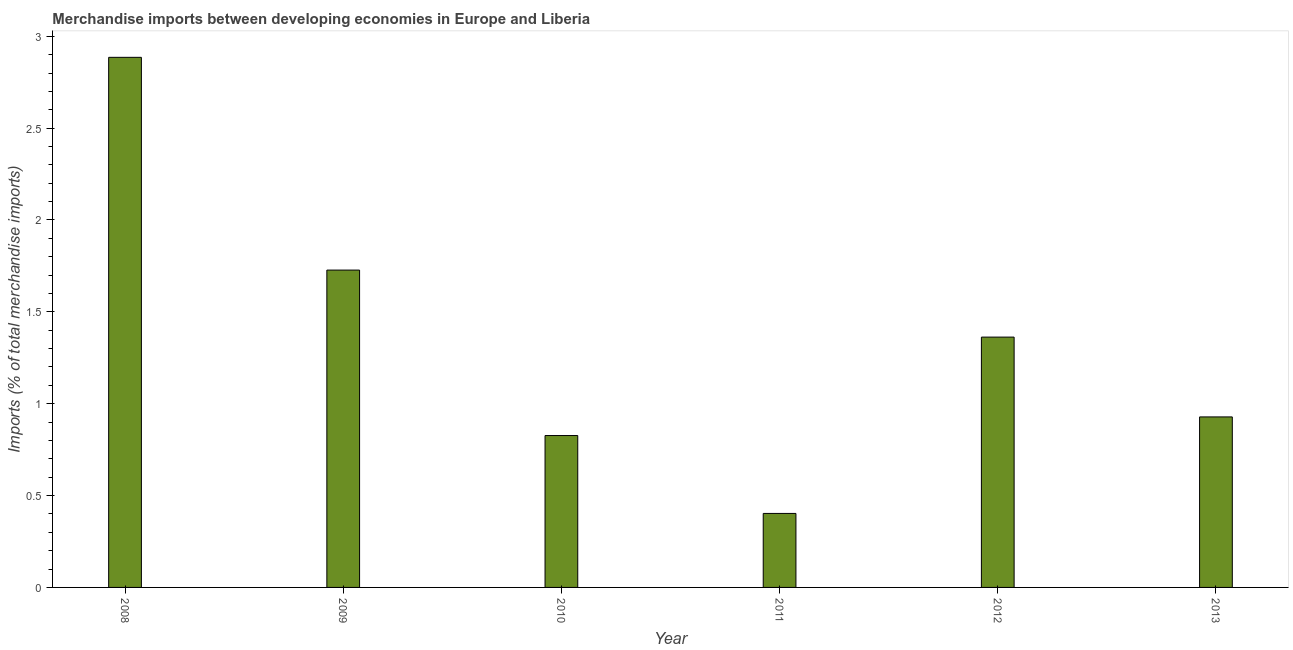Does the graph contain any zero values?
Offer a very short reply. No. What is the title of the graph?
Make the answer very short. Merchandise imports between developing economies in Europe and Liberia. What is the label or title of the X-axis?
Give a very brief answer. Year. What is the label or title of the Y-axis?
Provide a succinct answer. Imports (% of total merchandise imports). What is the merchandise imports in 2011?
Give a very brief answer. 0.4. Across all years, what is the maximum merchandise imports?
Your response must be concise. 2.89. Across all years, what is the minimum merchandise imports?
Make the answer very short. 0.4. In which year was the merchandise imports maximum?
Your answer should be very brief. 2008. What is the sum of the merchandise imports?
Your answer should be compact. 8.13. What is the difference between the merchandise imports in 2009 and 2013?
Give a very brief answer. 0.8. What is the average merchandise imports per year?
Keep it short and to the point. 1.35. What is the median merchandise imports?
Keep it short and to the point. 1.15. In how many years, is the merchandise imports greater than 1.3 %?
Offer a terse response. 3. What is the ratio of the merchandise imports in 2010 to that in 2012?
Provide a succinct answer. 0.61. Is the merchandise imports in 2008 less than that in 2011?
Your answer should be very brief. No. Is the difference between the merchandise imports in 2010 and 2012 greater than the difference between any two years?
Give a very brief answer. No. What is the difference between the highest and the second highest merchandise imports?
Provide a short and direct response. 1.16. Is the sum of the merchandise imports in 2011 and 2012 greater than the maximum merchandise imports across all years?
Provide a succinct answer. No. What is the difference between the highest and the lowest merchandise imports?
Provide a succinct answer. 2.48. In how many years, is the merchandise imports greater than the average merchandise imports taken over all years?
Keep it short and to the point. 3. How many bars are there?
Provide a short and direct response. 6. What is the Imports (% of total merchandise imports) in 2008?
Offer a very short reply. 2.89. What is the Imports (% of total merchandise imports) in 2009?
Offer a terse response. 1.73. What is the Imports (% of total merchandise imports) of 2010?
Provide a short and direct response. 0.83. What is the Imports (% of total merchandise imports) of 2011?
Keep it short and to the point. 0.4. What is the Imports (% of total merchandise imports) in 2012?
Your answer should be very brief. 1.36. What is the Imports (% of total merchandise imports) of 2013?
Provide a short and direct response. 0.93. What is the difference between the Imports (% of total merchandise imports) in 2008 and 2009?
Ensure brevity in your answer.  1.16. What is the difference between the Imports (% of total merchandise imports) in 2008 and 2010?
Give a very brief answer. 2.06. What is the difference between the Imports (% of total merchandise imports) in 2008 and 2011?
Provide a short and direct response. 2.48. What is the difference between the Imports (% of total merchandise imports) in 2008 and 2012?
Provide a succinct answer. 1.52. What is the difference between the Imports (% of total merchandise imports) in 2008 and 2013?
Make the answer very short. 1.96. What is the difference between the Imports (% of total merchandise imports) in 2009 and 2010?
Provide a short and direct response. 0.9. What is the difference between the Imports (% of total merchandise imports) in 2009 and 2011?
Your response must be concise. 1.32. What is the difference between the Imports (% of total merchandise imports) in 2009 and 2012?
Your response must be concise. 0.36. What is the difference between the Imports (% of total merchandise imports) in 2009 and 2013?
Offer a terse response. 0.8. What is the difference between the Imports (% of total merchandise imports) in 2010 and 2011?
Provide a succinct answer. 0.42. What is the difference between the Imports (% of total merchandise imports) in 2010 and 2012?
Give a very brief answer. -0.54. What is the difference between the Imports (% of total merchandise imports) in 2010 and 2013?
Offer a terse response. -0.1. What is the difference between the Imports (% of total merchandise imports) in 2011 and 2012?
Offer a terse response. -0.96. What is the difference between the Imports (% of total merchandise imports) in 2011 and 2013?
Keep it short and to the point. -0.53. What is the difference between the Imports (% of total merchandise imports) in 2012 and 2013?
Offer a very short reply. 0.43. What is the ratio of the Imports (% of total merchandise imports) in 2008 to that in 2009?
Make the answer very short. 1.67. What is the ratio of the Imports (% of total merchandise imports) in 2008 to that in 2010?
Your answer should be very brief. 3.49. What is the ratio of the Imports (% of total merchandise imports) in 2008 to that in 2011?
Give a very brief answer. 7.17. What is the ratio of the Imports (% of total merchandise imports) in 2008 to that in 2012?
Ensure brevity in your answer.  2.12. What is the ratio of the Imports (% of total merchandise imports) in 2008 to that in 2013?
Make the answer very short. 3.11. What is the ratio of the Imports (% of total merchandise imports) in 2009 to that in 2010?
Your response must be concise. 2.09. What is the ratio of the Imports (% of total merchandise imports) in 2009 to that in 2011?
Give a very brief answer. 4.29. What is the ratio of the Imports (% of total merchandise imports) in 2009 to that in 2012?
Give a very brief answer. 1.27. What is the ratio of the Imports (% of total merchandise imports) in 2009 to that in 2013?
Ensure brevity in your answer.  1.86. What is the ratio of the Imports (% of total merchandise imports) in 2010 to that in 2011?
Provide a succinct answer. 2.05. What is the ratio of the Imports (% of total merchandise imports) in 2010 to that in 2012?
Provide a short and direct response. 0.61. What is the ratio of the Imports (% of total merchandise imports) in 2010 to that in 2013?
Your response must be concise. 0.89. What is the ratio of the Imports (% of total merchandise imports) in 2011 to that in 2012?
Offer a terse response. 0.3. What is the ratio of the Imports (% of total merchandise imports) in 2011 to that in 2013?
Offer a terse response. 0.43. What is the ratio of the Imports (% of total merchandise imports) in 2012 to that in 2013?
Keep it short and to the point. 1.47. 